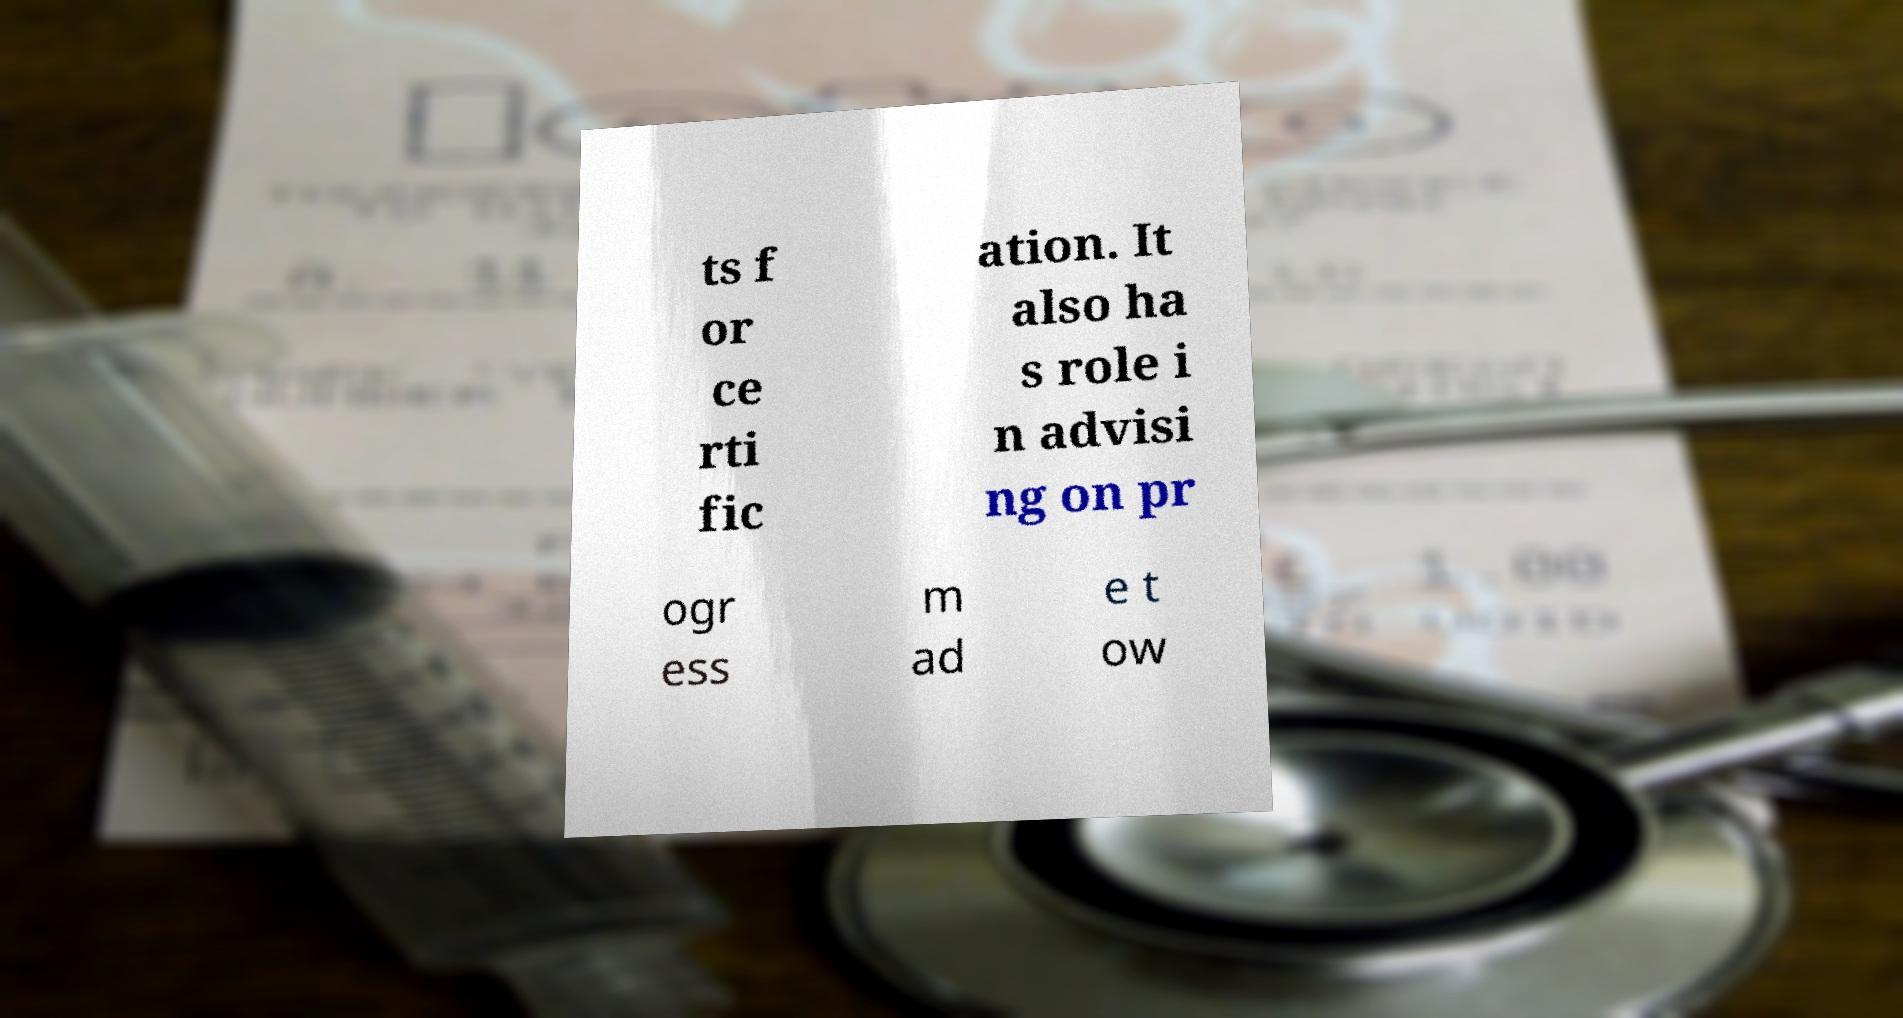I need the written content from this picture converted into text. Can you do that? ts f or ce rti fic ation. It also ha s role i n advisi ng on pr ogr ess m ad e t ow 